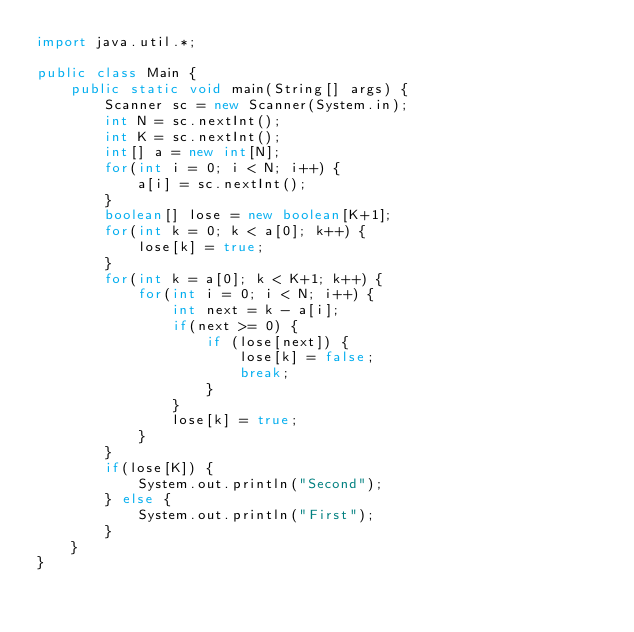Convert code to text. <code><loc_0><loc_0><loc_500><loc_500><_Java_>import java.util.*;

public class Main {
    public static void main(String[] args) {
        Scanner sc = new Scanner(System.in);
        int N = sc.nextInt();
        int K = sc.nextInt();
        int[] a = new int[N];
        for(int i = 0; i < N; i++) {
            a[i] = sc.nextInt();
        }
        boolean[] lose = new boolean[K+1];
        for(int k = 0; k < a[0]; k++) {
            lose[k] = true;
        }
        for(int k = a[0]; k < K+1; k++) {
            for(int i = 0; i < N; i++) {
                int next = k - a[i];
                if(next >= 0) {
                    if (lose[next]) {
                        lose[k] = false;
                        break;
                    }
                }
                lose[k] = true;
            }
        }
        if(lose[K]) {
            System.out.println("Second");
        } else {
            System.out.println("First");
        }
    }
}</code> 